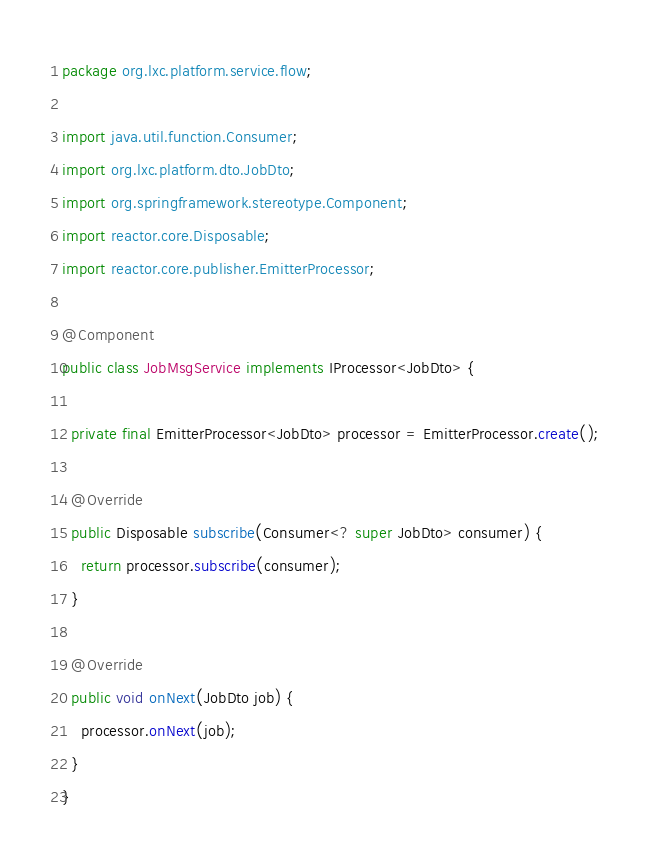<code> <loc_0><loc_0><loc_500><loc_500><_Java_>package org.lxc.platform.service.flow;

import java.util.function.Consumer;
import org.lxc.platform.dto.JobDto;
import org.springframework.stereotype.Component;
import reactor.core.Disposable;
import reactor.core.publisher.EmitterProcessor;

@Component
public class JobMsgService implements IProcessor<JobDto> {

  private final EmitterProcessor<JobDto> processor = EmitterProcessor.create();

  @Override
  public Disposable subscribe(Consumer<? super JobDto> consumer) {
    return processor.subscribe(consumer);
  }

  @Override
  public void onNext(JobDto job) {
    processor.onNext(job);
  }
}
</code> 